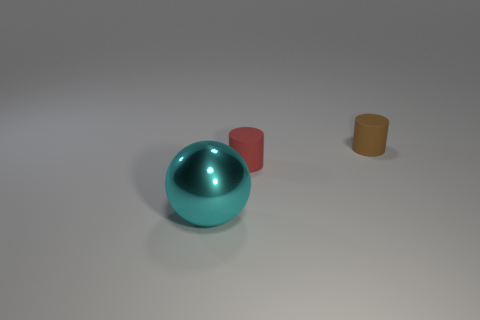What time of day and setting does the lighting in the image suggest? The image appears to be lit by a diffuse and neutral light source, suggesting an interior setting under artificial lighting. There are no strong shadows or indications of natural light, which may imply an overcast day or simply indoor lighting at any time of day. 